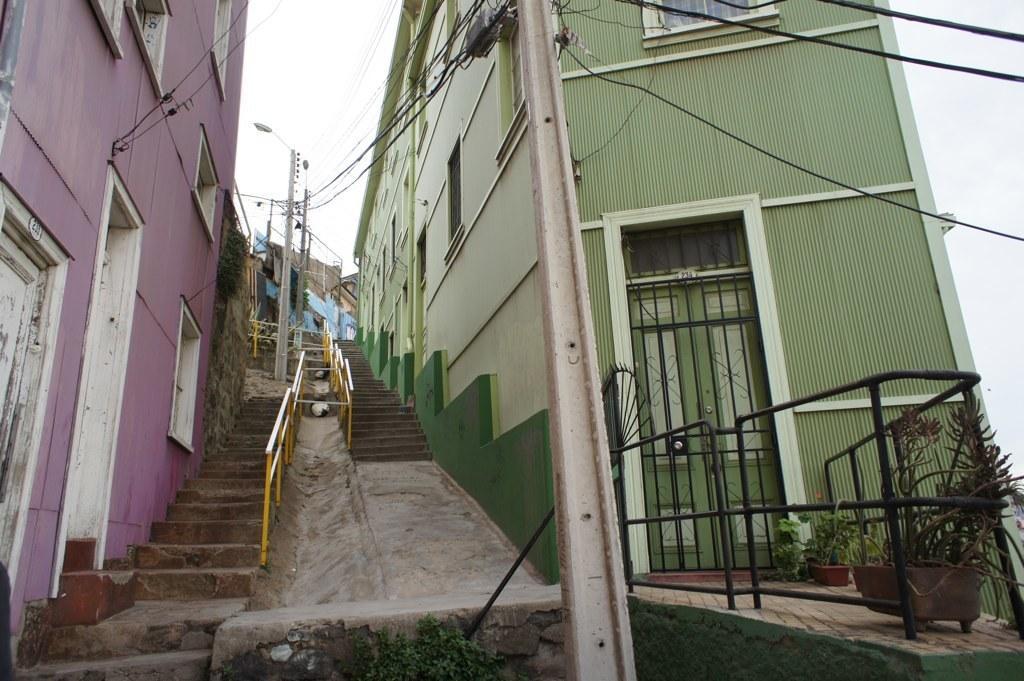Could you give a brief overview of what you see in this image? In this image we can see few buildings with doors and windows and there are some potted plants. We can see few power poles and street lights and we can see two staircases and at the top we can see the sky. 